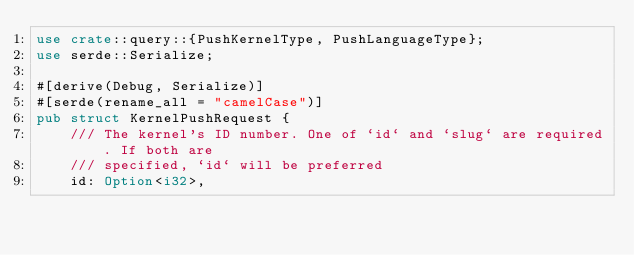Convert code to text. <code><loc_0><loc_0><loc_500><loc_500><_Rust_>use crate::query::{PushKernelType, PushLanguageType};
use serde::Serialize;

#[derive(Debug, Serialize)]
#[serde(rename_all = "camelCase")]
pub struct KernelPushRequest {
    /// The kernel's ID number. One of `id` and `slug` are required. If both are
    /// specified, `id` will be preferred
    id: Option<i32>,</code> 